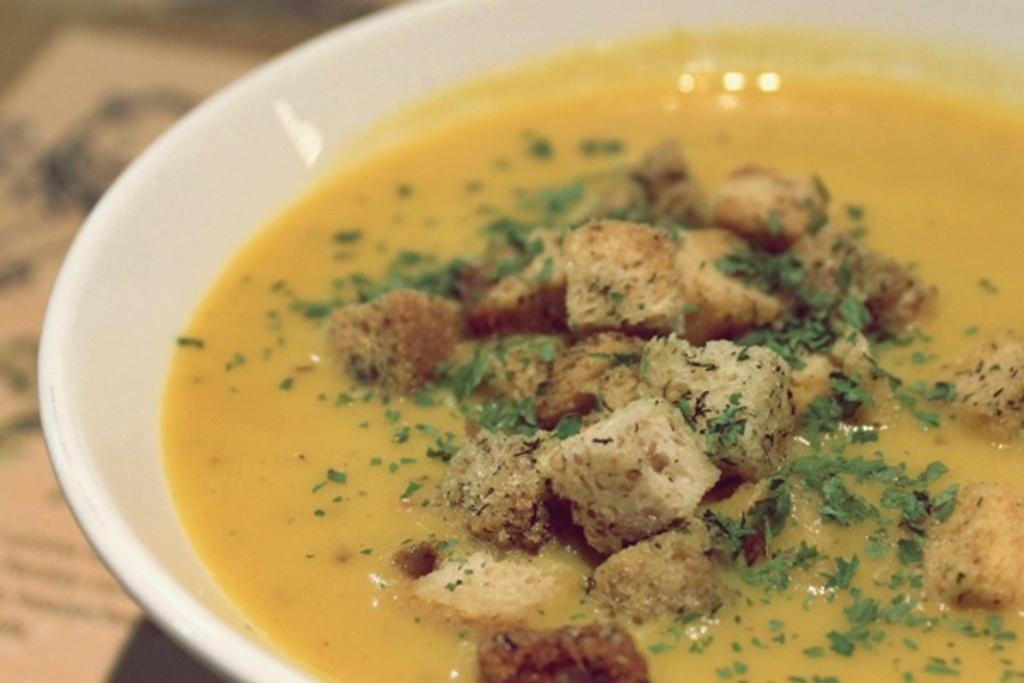What is located in the foreground of the image? There is a bowl in the foreground of the image. What is inside the bowl? There is food in the bowl. Can you describe anything visible in the background of the image? There is an object visible in the background of the image. Can you tell me how many rabbits are hopping on the sidewalk in the image? There are no rabbits or sidewalks present in the image. 